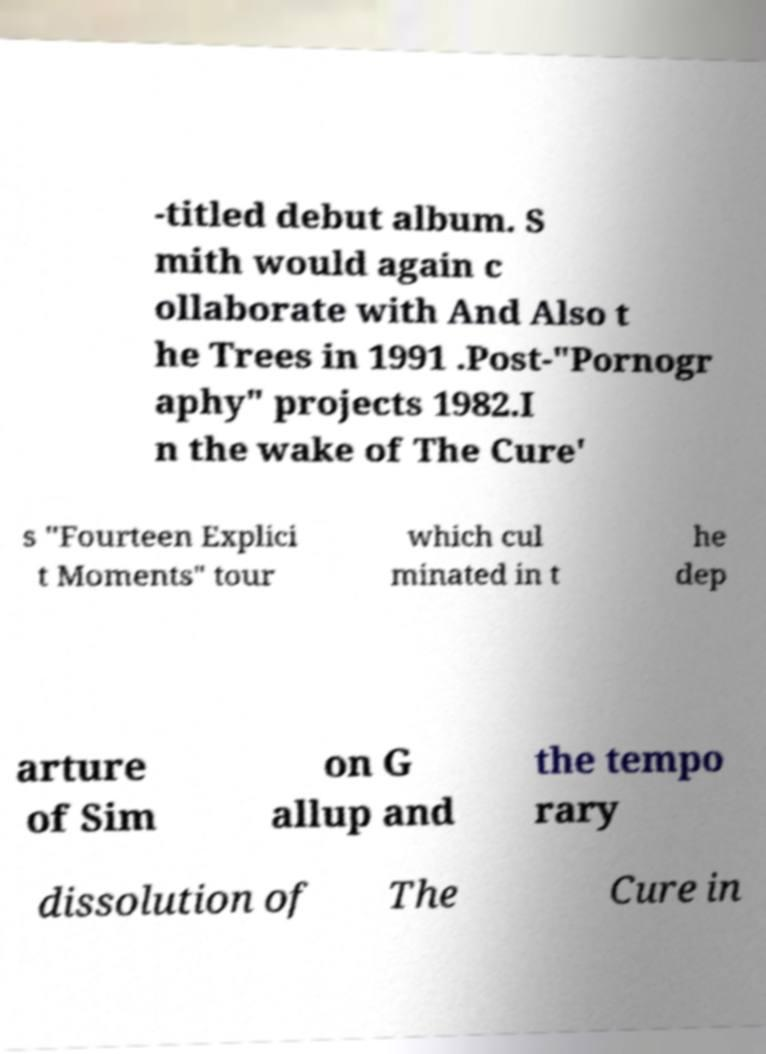There's text embedded in this image that I need extracted. Can you transcribe it verbatim? -titled debut album. S mith would again c ollaborate with And Also t he Trees in 1991 .Post-"Pornogr aphy" projects 1982.I n the wake of The Cure' s "Fourteen Explici t Moments" tour which cul minated in t he dep arture of Sim on G allup and the tempo rary dissolution of The Cure in 